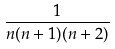Convert formula to latex. <formula><loc_0><loc_0><loc_500><loc_500>\frac { 1 } { n ( n + 1 ) ( n + 2 ) }</formula> 